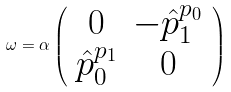Convert formula to latex. <formula><loc_0><loc_0><loc_500><loc_500>\omega = \alpha \left ( \begin{array} { c c } 0 & - \hat { p } _ { 1 } ^ { p _ { 0 } } \\ \hat { p } _ { 0 } ^ { p _ { 1 } } & 0 \end{array} \right )</formula> 